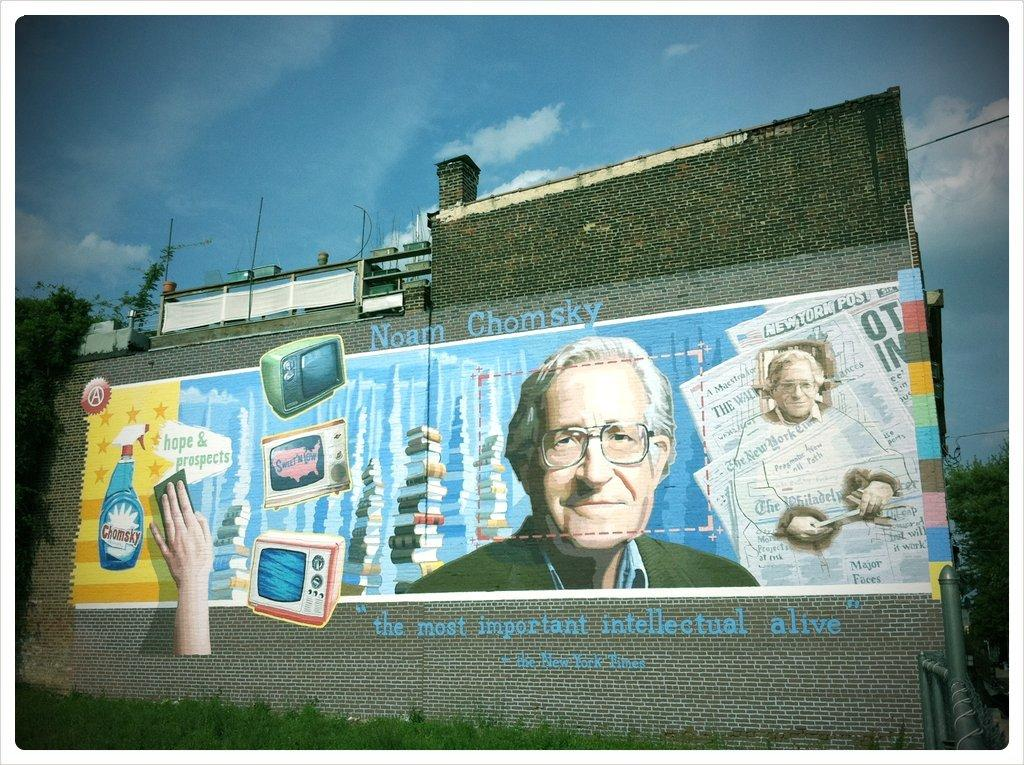<image>
Create a compact narrative representing the image presented. A painting on the side of the building of Noam Comsky. 